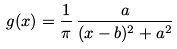Convert formula to latex. <formula><loc_0><loc_0><loc_500><loc_500>g ( x ) = \frac { 1 } { \pi } \, \frac { a } { ( x - b ) ^ { 2 } + a ^ { 2 } }</formula> 